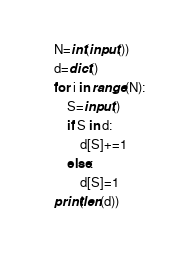<code> <loc_0><loc_0><loc_500><loc_500><_Python_>N=int(input())
d=dict()
for i in range(N):
    S=input()
    if S in d:
        d[S]+=1
    else:
        d[S]=1
print(len(d))</code> 